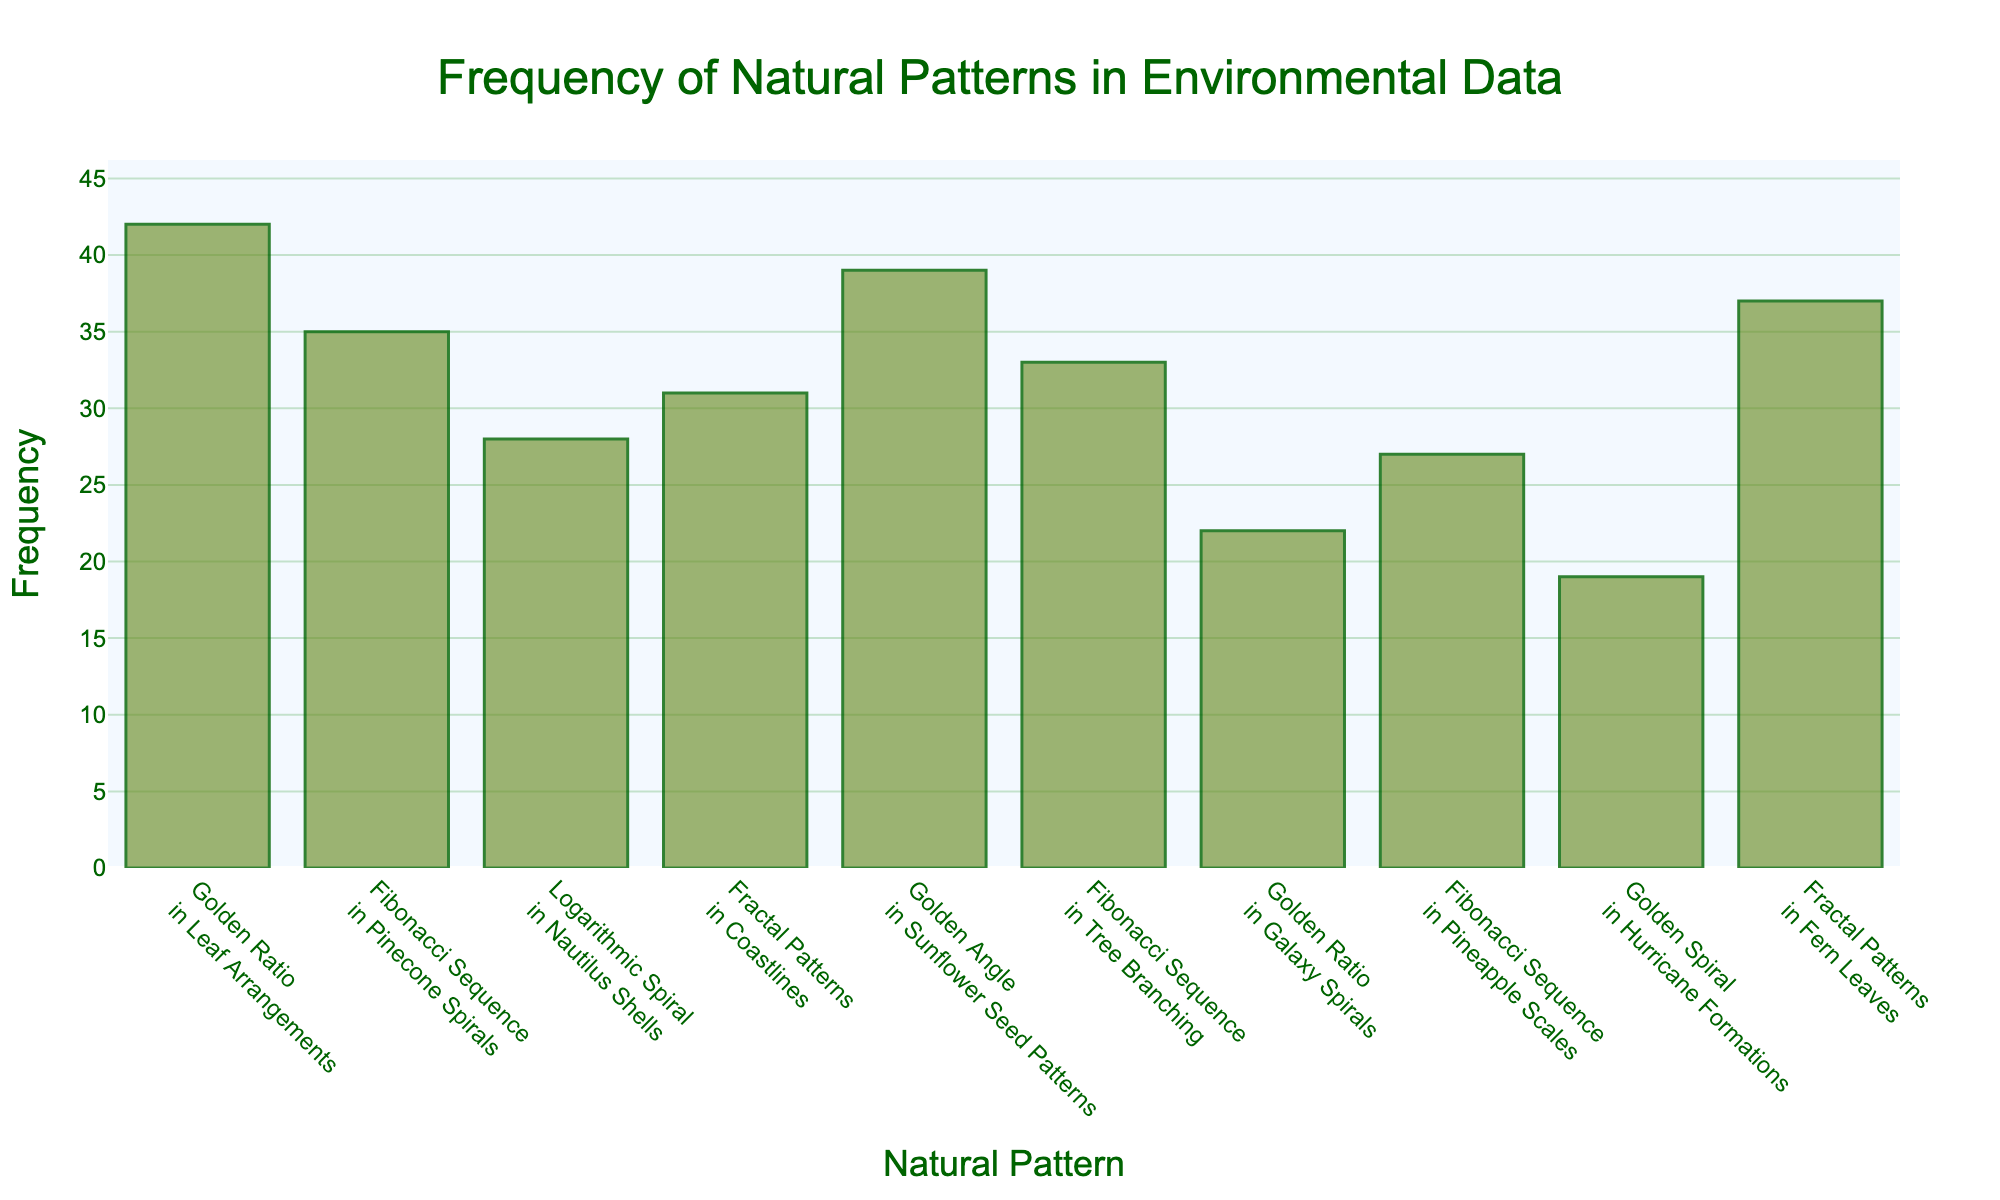What's the title of the figure? The title of a figure is usually positioned at the top and is often the largest text element, making it easy to spot. The title in this figure is displayed prominently in dark green with a font size of 24.
Answer: Frequency of Natural Patterns in Environmental Data What is the frequency of the Golden Spiral in Hurricane Formations? To find this, look for the bar associated with "Golden Spiral in Hurricane Formations" on the x-axis and read off the corresponding y-axis value.
Answer: 19 How many natural patterns have frequencies greater than 30? Identify the bars that have y-values greater than 30 by checking each bar's height against the y-axis marks. Count these bars.
Answer: 5 Which natural pattern has the highest frequency? To determine this, compare the heights of all the bars in the histogram and identify the one that reaches the highest point.
Answer: Golden Ratio in Leaf Arrangements What is the sum of the frequencies of the Fibonacci Sequence in Pinecone Spirals and Fractal Patterns in Fern Leaves? Find the individual frequencies for these patterns (35 and 37), then add them together.
Answer: 72 How does the frequency of Fibonacci Sequence in Pineapple Scales compare to the frequency of Logarithmic Spiral in Nautilus Shells? Compare the height of the bars for these two patterns to see which is taller or if they are equal.
Answer: Pineapple Scales is less frequent What's the difference in frequency between Golden Angle in Sunflower Seed Patterns and Golden Ratio in Galaxy Spirals? Find the frequencies for these patterns (39 and 22) and subtract the smaller one from the larger one.
Answer: 17 Which pattern observed has the least frequency, and what is its value? Identify the shortest bar in the histogram and read the value from the y-axis.
Answer: Golden Spiral in Hurricane Formations, 19 What is the median frequency of all patterns depicted in the histogram? List all frequencies: 19, 22, 27, 28, 31, 33, 35, 37, 39, 42. Since there are 10 entries, the median will be the average of the 5th and 6th values: (31 + 33)/2
Answer: 32 Are there more occurrences of fractal patterns in coastlines or in fern leaves? Compare the bar heights for "Fractal Patterns in Coastlines" and "Fractal Patterns in Fern Leaves."
Answer: Fern Leaves 